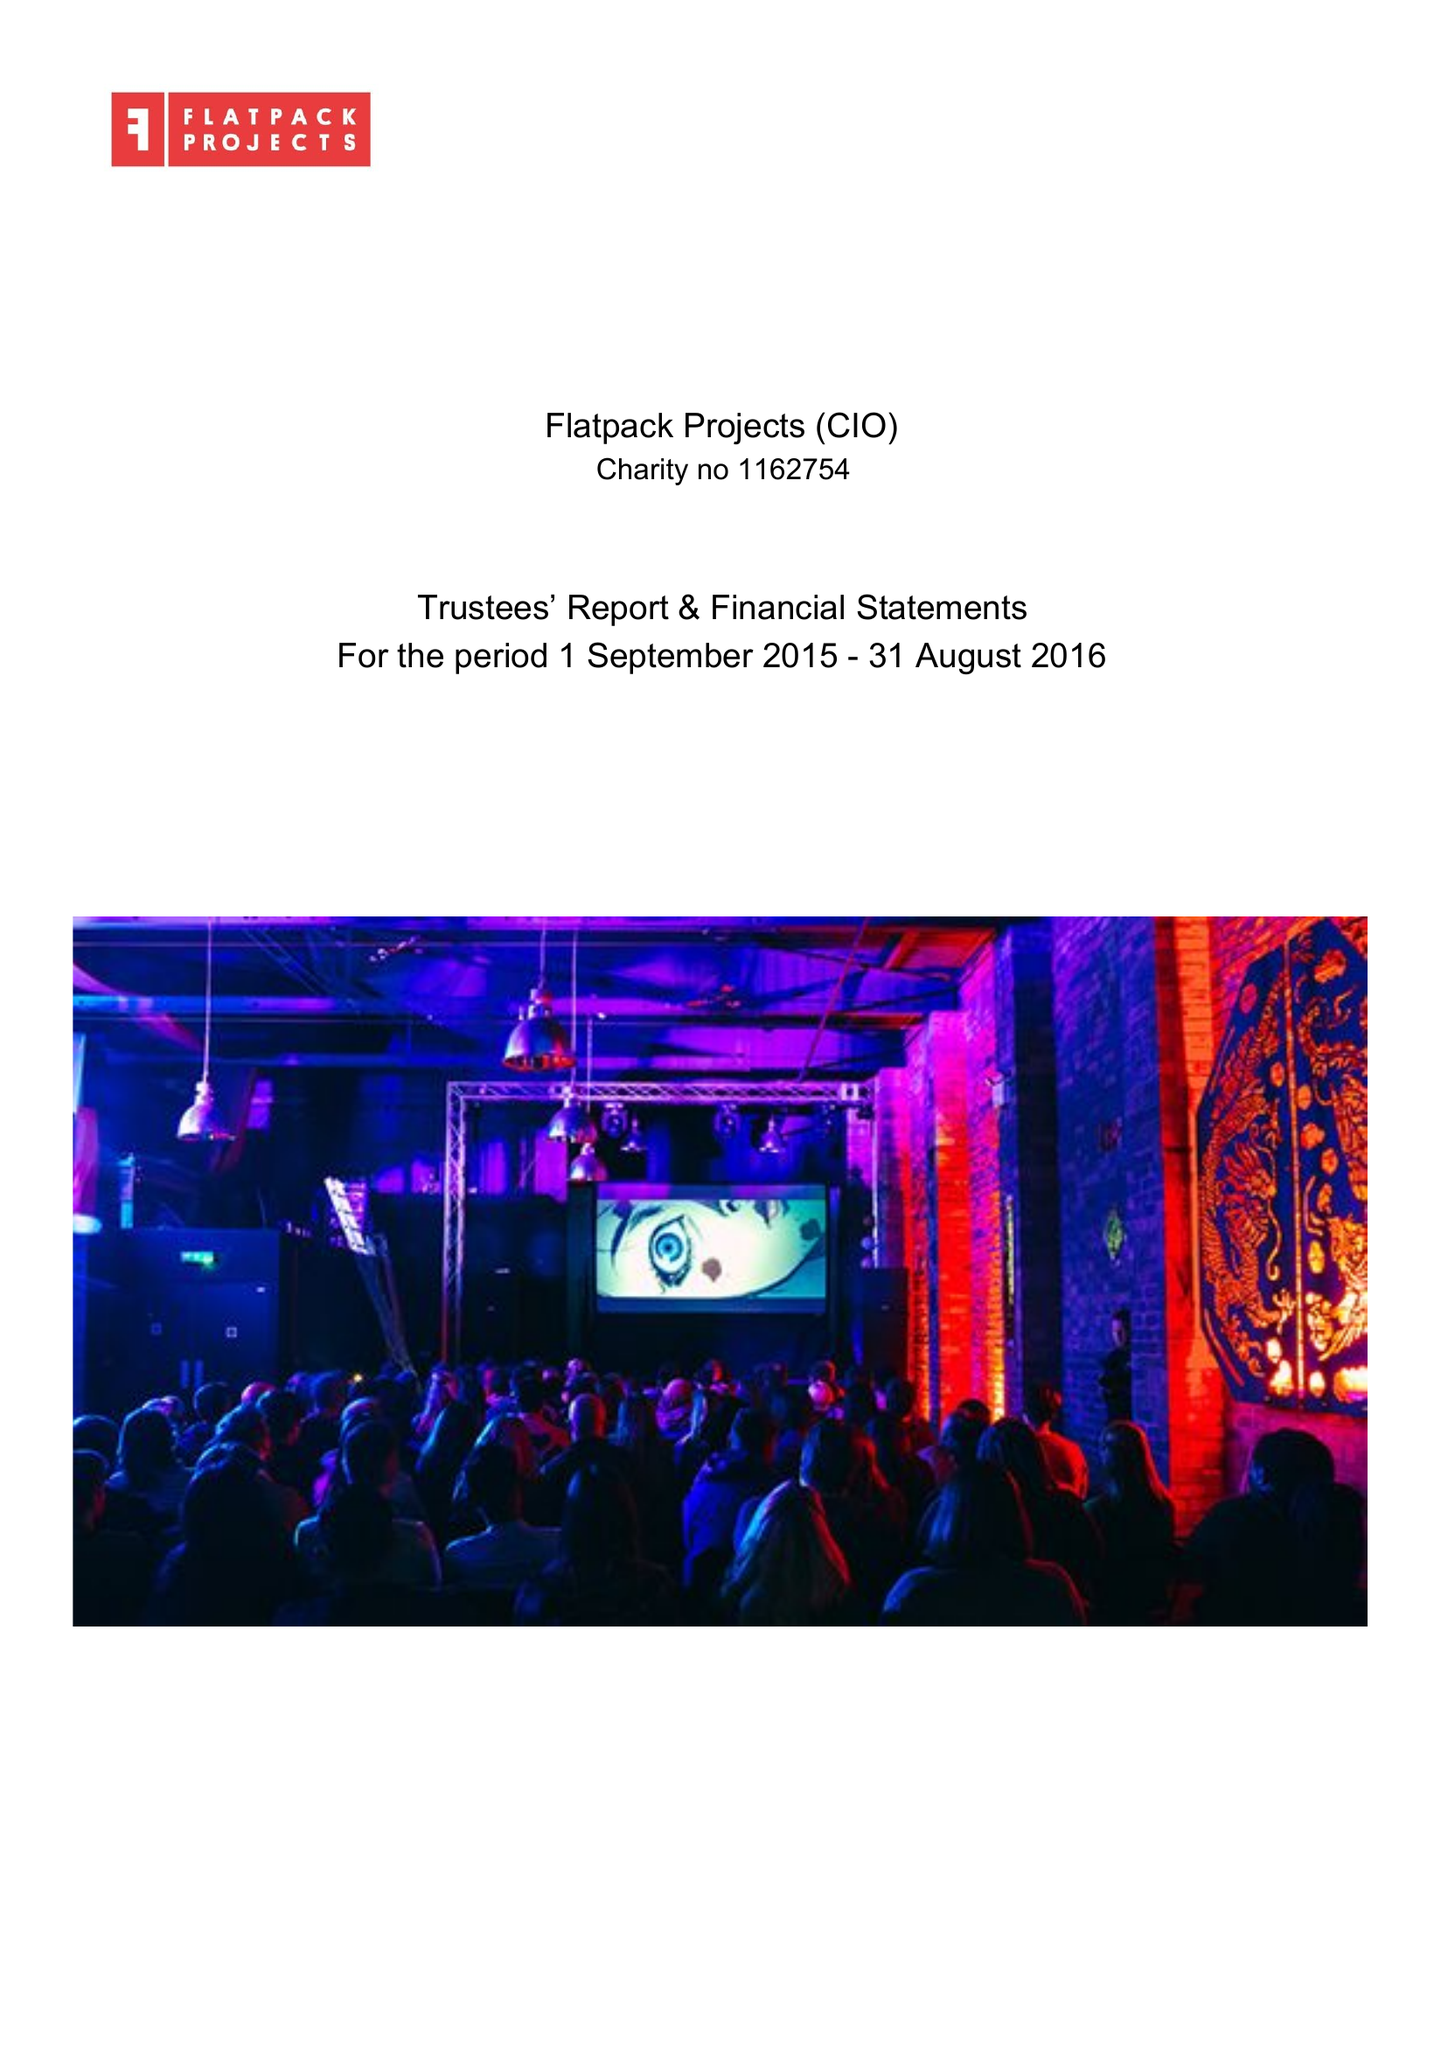What is the value for the address__post_town?
Answer the question using a single word or phrase. BIRMINGHAM 